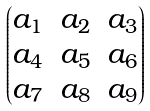Convert formula to latex. <formula><loc_0><loc_0><loc_500><loc_500>\begin{pmatrix} a _ { 1 } & a _ { 2 } & a _ { 3 } \\ a _ { 4 } & a _ { 5 } & a _ { 6 } \\ a _ { 7 } & a _ { 8 } & a _ { 9 } \end{pmatrix}</formula> 